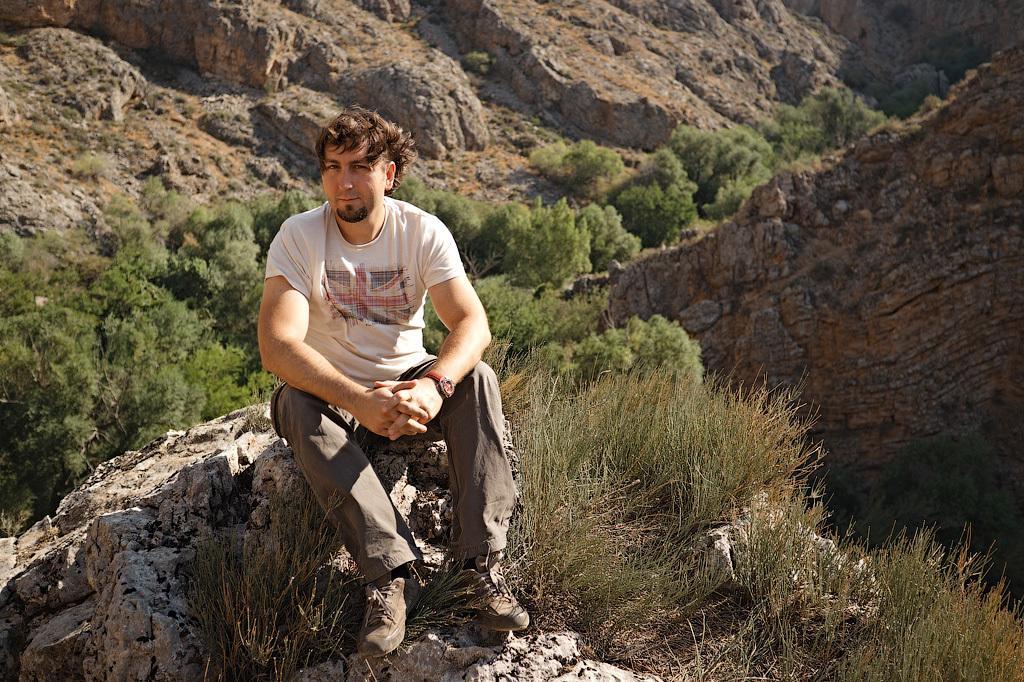How would you summarize this image in a sentence or two? In this image I can see a man is sitting in the front. I can see he is wearing white colour t shirt, a watch, pant and shoes. I can also see plants in the background and in the front. 